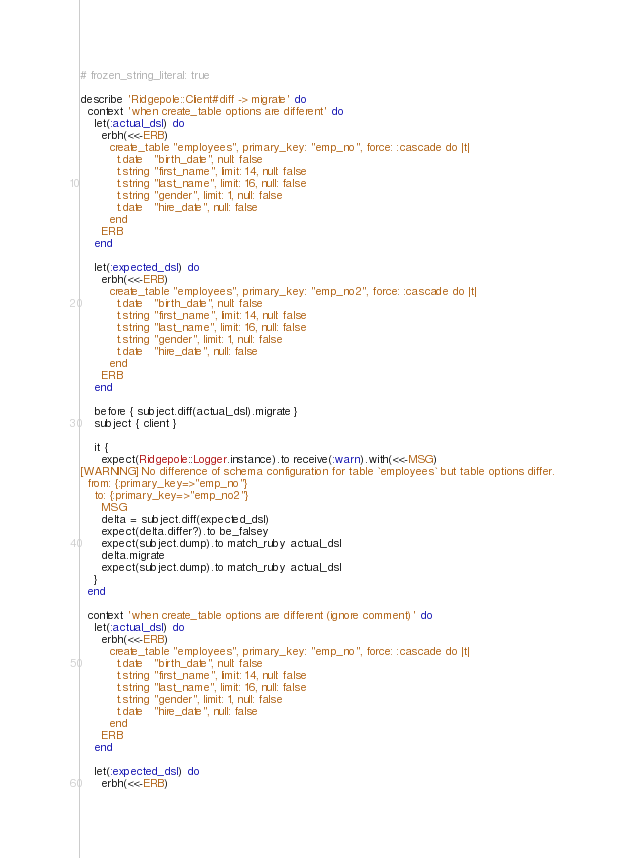Convert code to text. <code><loc_0><loc_0><loc_500><loc_500><_Ruby_># frozen_string_literal: true

describe 'Ridgepole::Client#diff -> migrate' do
  context 'when create_table options are different' do
    let(:actual_dsl) do
      erbh(<<-ERB)
        create_table "employees", primary_key: "emp_no", force: :cascade do |t|
          t.date   "birth_date", null: false
          t.string "first_name", limit: 14, null: false
          t.string "last_name", limit: 16, null: false
          t.string "gender", limit: 1, null: false
          t.date   "hire_date", null: false
        end
      ERB
    end

    let(:expected_dsl) do
      erbh(<<-ERB)
        create_table "employees", primary_key: "emp_no2", force: :cascade do |t|
          t.date   "birth_date", null: false
          t.string "first_name", limit: 14, null: false
          t.string "last_name", limit: 16, null: false
          t.string "gender", limit: 1, null: false
          t.date   "hire_date", null: false
        end
      ERB
    end

    before { subject.diff(actual_dsl).migrate }
    subject { client }

    it {
      expect(Ridgepole::Logger.instance).to receive(:warn).with(<<-MSG)
[WARNING] No difference of schema configuration for table `employees` but table options differ.
  from: {:primary_key=>"emp_no"}
    to: {:primary_key=>"emp_no2"}
      MSG
      delta = subject.diff(expected_dsl)
      expect(delta.differ?).to be_falsey
      expect(subject.dump).to match_ruby actual_dsl
      delta.migrate
      expect(subject.dump).to match_ruby actual_dsl
    }
  end

  context 'when create_table options are different (ignore comment)' do
    let(:actual_dsl) do
      erbh(<<-ERB)
        create_table "employees", primary_key: "emp_no", force: :cascade do |t|
          t.date   "birth_date", null: false
          t.string "first_name", limit: 14, null: false
          t.string "last_name", limit: 16, null: false
          t.string "gender", limit: 1, null: false
          t.date   "hire_date", null: false
        end
      ERB
    end

    let(:expected_dsl) do
      erbh(<<-ERB)</code> 